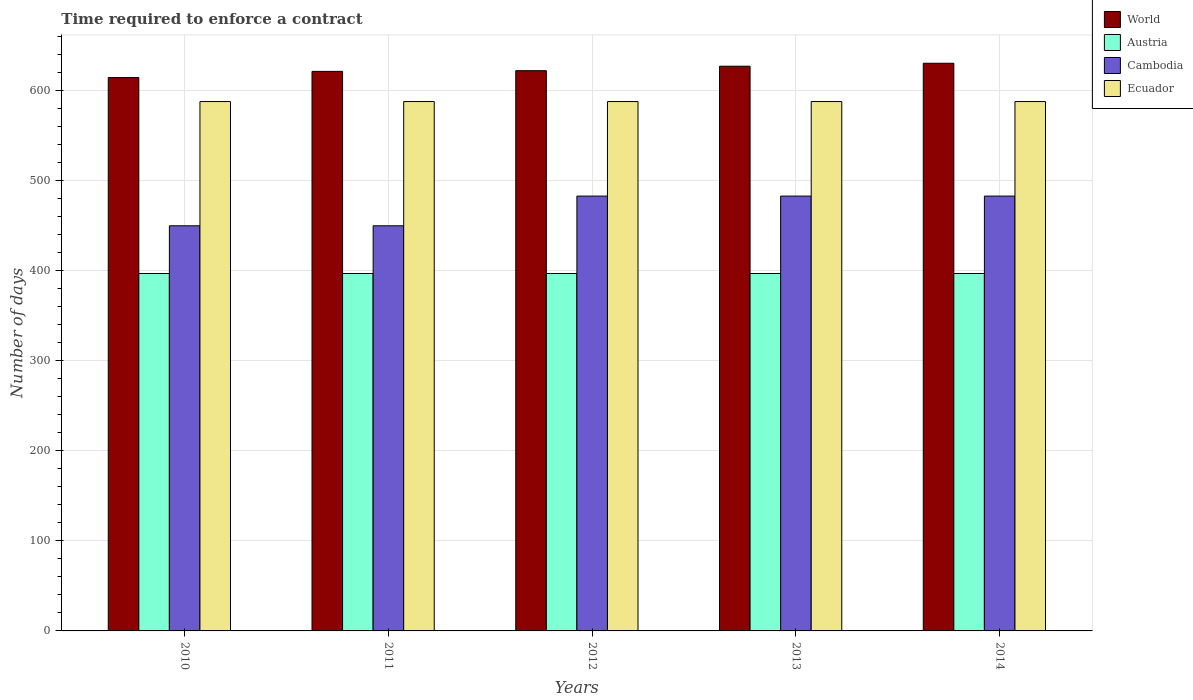What is the label of the 4th group of bars from the left?
Give a very brief answer. 2013. What is the number of days required to enforce a contract in Cambodia in 2014?
Your answer should be very brief. 483. Across all years, what is the maximum number of days required to enforce a contract in Cambodia?
Make the answer very short. 483. Across all years, what is the minimum number of days required to enforce a contract in World?
Your response must be concise. 614.64. In which year was the number of days required to enforce a contract in World maximum?
Keep it short and to the point. 2014. In which year was the number of days required to enforce a contract in World minimum?
Ensure brevity in your answer.  2010. What is the total number of days required to enforce a contract in Ecuador in the graph?
Keep it short and to the point. 2940. What is the difference between the number of days required to enforce a contract in Austria in 2010 and that in 2014?
Offer a very short reply. 0. What is the difference between the number of days required to enforce a contract in Cambodia in 2011 and the number of days required to enforce a contract in Ecuador in 2013?
Your answer should be very brief. -138. What is the average number of days required to enforce a contract in Austria per year?
Your response must be concise. 397. In the year 2012, what is the difference between the number of days required to enforce a contract in Ecuador and number of days required to enforce a contract in Cambodia?
Your response must be concise. 105. What is the ratio of the number of days required to enforce a contract in Cambodia in 2010 to that in 2012?
Your answer should be very brief. 0.93. What is the difference between the highest and the second highest number of days required to enforce a contract in Ecuador?
Offer a terse response. 0. Is the sum of the number of days required to enforce a contract in Cambodia in 2011 and 2012 greater than the maximum number of days required to enforce a contract in World across all years?
Make the answer very short. Yes. Is it the case that in every year, the sum of the number of days required to enforce a contract in Cambodia and number of days required to enforce a contract in World is greater than the number of days required to enforce a contract in Austria?
Give a very brief answer. Yes. How many bars are there?
Provide a short and direct response. 20. Are all the bars in the graph horizontal?
Your response must be concise. No. Are the values on the major ticks of Y-axis written in scientific E-notation?
Keep it short and to the point. No. Does the graph contain grids?
Your response must be concise. Yes. What is the title of the graph?
Your answer should be very brief. Time required to enforce a contract. Does "Cambodia" appear as one of the legend labels in the graph?
Your answer should be very brief. Yes. What is the label or title of the X-axis?
Give a very brief answer. Years. What is the label or title of the Y-axis?
Keep it short and to the point. Number of days. What is the Number of days of World in 2010?
Offer a terse response. 614.64. What is the Number of days of Austria in 2010?
Your answer should be compact. 397. What is the Number of days in Cambodia in 2010?
Your response must be concise. 450. What is the Number of days of Ecuador in 2010?
Offer a very short reply. 588. What is the Number of days of World in 2011?
Your response must be concise. 621.51. What is the Number of days in Austria in 2011?
Make the answer very short. 397. What is the Number of days in Cambodia in 2011?
Make the answer very short. 450. What is the Number of days in Ecuador in 2011?
Keep it short and to the point. 588. What is the Number of days in World in 2012?
Ensure brevity in your answer.  622.29. What is the Number of days of Austria in 2012?
Keep it short and to the point. 397. What is the Number of days in Cambodia in 2012?
Make the answer very short. 483. What is the Number of days of Ecuador in 2012?
Your response must be concise. 588. What is the Number of days in World in 2013?
Offer a very short reply. 627.26. What is the Number of days in Austria in 2013?
Offer a terse response. 397. What is the Number of days of Cambodia in 2013?
Keep it short and to the point. 483. What is the Number of days in Ecuador in 2013?
Provide a succinct answer. 588. What is the Number of days in World in 2014?
Your response must be concise. 630.54. What is the Number of days in Austria in 2014?
Give a very brief answer. 397. What is the Number of days in Cambodia in 2014?
Your response must be concise. 483. What is the Number of days in Ecuador in 2014?
Provide a succinct answer. 588. Across all years, what is the maximum Number of days of World?
Offer a very short reply. 630.54. Across all years, what is the maximum Number of days of Austria?
Your answer should be compact. 397. Across all years, what is the maximum Number of days of Cambodia?
Your answer should be compact. 483. Across all years, what is the maximum Number of days in Ecuador?
Your response must be concise. 588. Across all years, what is the minimum Number of days in World?
Your answer should be very brief. 614.64. Across all years, what is the minimum Number of days of Austria?
Provide a short and direct response. 397. Across all years, what is the minimum Number of days in Cambodia?
Ensure brevity in your answer.  450. Across all years, what is the minimum Number of days of Ecuador?
Provide a short and direct response. 588. What is the total Number of days of World in the graph?
Keep it short and to the point. 3116.23. What is the total Number of days of Austria in the graph?
Offer a very short reply. 1985. What is the total Number of days in Cambodia in the graph?
Your answer should be very brief. 2349. What is the total Number of days in Ecuador in the graph?
Your answer should be very brief. 2940. What is the difference between the Number of days in World in 2010 and that in 2011?
Offer a very short reply. -6.87. What is the difference between the Number of days in Austria in 2010 and that in 2011?
Offer a terse response. 0. What is the difference between the Number of days in Cambodia in 2010 and that in 2011?
Your response must be concise. 0. What is the difference between the Number of days in World in 2010 and that in 2012?
Give a very brief answer. -7.65. What is the difference between the Number of days of Austria in 2010 and that in 2012?
Your answer should be compact. 0. What is the difference between the Number of days of Cambodia in 2010 and that in 2012?
Give a very brief answer. -33. What is the difference between the Number of days of World in 2010 and that in 2013?
Ensure brevity in your answer.  -12.62. What is the difference between the Number of days in Austria in 2010 and that in 2013?
Provide a succinct answer. 0. What is the difference between the Number of days of Cambodia in 2010 and that in 2013?
Your answer should be very brief. -33. What is the difference between the Number of days of Ecuador in 2010 and that in 2013?
Offer a very short reply. 0. What is the difference between the Number of days of World in 2010 and that in 2014?
Offer a very short reply. -15.9. What is the difference between the Number of days of Austria in 2010 and that in 2014?
Your response must be concise. 0. What is the difference between the Number of days of Cambodia in 2010 and that in 2014?
Provide a short and direct response. -33. What is the difference between the Number of days in Ecuador in 2010 and that in 2014?
Give a very brief answer. 0. What is the difference between the Number of days of World in 2011 and that in 2012?
Your response must be concise. -0.78. What is the difference between the Number of days in Cambodia in 2011 and that in 2012?
Your answer should be very brief. -33. What is the difference between the Number of days of World in 2011 and that in 2013?
Ensure brevity in your answer.  -5.75. What is the difference between the Number of days of Cambodia in 2011 and that in 2013?
Offer a terse response. -33. What is the difference between the Number of days of World in 2011 and that in 2014?
Offer a terse response. -9.03. What is the difference between the Number of days in Cambodia in 2011 and that in 2014?
Give a very brief answer. -33. What is the difference between the Number of days in World in 2012 and that in 2013?
Offer a terse response. -4.97. What is the difference between the Number of days in Cambodia in 2012 and that in 2013?
Your response must be concise. 0. What is the difference between the Number of days in Ecuador in 2012 and that in 2013?
Make the answer very short. 0. What is the difference between the Number of days of World in 2012 and that in 2014?
Offer a terse response. -8.25. What is the difference between the Number of days of Austria in 2012 and that in 2014?
Offer a terse response. 0. What is the difference between the Number of days of World in 2013 and that in 2014?
Your answer should be very brief. -3.28. What is the difference between the Number of days in World in 2010 and the Number of days in Austria in 2011?
Your answer should be very brief. 217.64. What is the difference between the Number of days in World in 2010 and the Number of days in Cambodia in 2011?
Offer a very short reply. 164.64. What is the difference between the Number of days of World in 2010 and the Number of days of Ecuador in 2011?
Your response must be concise. 26.64. What is the difference between the Number of days of Austria in 2010 and the Number of days of Cambodia in 2011?
Your response must be concise. -53. What is the difference between the Number of days in Austria in 2010 and the Number of days in Ecuador in 2011?
Make the answer very short. -191. What is the difference between the Number of days in Cambodia in 2010 and the Number of days in Ecuador in 2011?
Your answer should be very brief. -138. What is the difference between the Number of days in World in 2010 and the Number of days in Austria in 2012?
Your answer should be very brief. 217.64. What is the difference between the Number of days of World in 2010 and the Number of days of Cambodia in 2012?
Offer a very short reply. 131.64. What is the difference between the Number of days of World in 2010 and the Number of days of Ecuador in 2012?
Offer a terse response. 26.64. What is the difference between the Number of days in Austria in 2010 and the Number of days in Cambodia in 2012?
Give a very brief answer. -86. What is the difference between the Number of days in Austria in 2010 and the Number of days in Ecuador in 2012?
Your answer should be very brief. -191. What is the difference between the Number of days in Cambodia in 2010 and the Number of days in Ecuador in 2012?
Offer a very short reply. -138. What is the difference between the Number of days of World in 2010 and the Number of days of Austria in 2013?
Ensure brevity in your answer.  217.64. What is the difference between the Number of days in World in 2010 and the Number of days in Cambodia in 2013?
Give a very brief answer. 131.64. What is the difference between the Number of days in World in 2010 and the Number of days in Ecuador in 2013?
Provide a succinct answer. 26.64. What is the difference between the Number of days of Austria in 2010 and the Number of days of Cambodia in 2013?
Provide a short and direct response. -86. What is the difference between the Number of days of Austria in 2010 and the Number of days of Ecuador in 2013?
Provide a short and direct response. -191. What is the difference between the Number of days of Cambodia in 2010 and the Number of days of Ecuador in 2013?
Offer a very short reply. -138. What is the difference between the Number of days in World in 2010 and the Number of days in Austria in 2014?
Your response must be concise. 217.64. What is the difference between the Number of days in World in 2010 and the Number of days in Cambodia in 2014?
Your answer should be very brief. 131.64. What is the difference between the Number of days in World in 2010 and the Number of days in Ecuador in 2014?
Your answer should be compact. 26.64. What is the difference between the Number of days of Austria in 2010 and the Number of days of Cambodia in 2014?
Your answer should be very brief. -86. What is the difference between the Number of days in Austria in 2010 and the Number of days in Ecuador in 2014?
Offer a very short reply. -191. What is the difference between the Number of days in Cambodia in 2010 and the Number of days in Ecuador in 2014?
Keep it short and to the point. -138. What is the difference between the Number of days of World in 2011 and the Number of days of Austria in 2012?
Provide a succinct answer. 224.51. What is the difference between the Number of days in World in 2011 and the Number of days in Cambodia in 2012?
Your answer should be compact. 138.51. What is the difference between the Number of days in World in 2011 and the Number of days in Ecuador in 2012?
Offer a very short reply. 33.51. What is the difference between the Number of days in Austria in 2011 and the Number of days in Cambodia in 2012?
Ensure brevity in your answer.  -86. What is the difference between the Number of days in Austria in 2011 and the Number of days in Ecuador in 2012?
Your response must be concise. -191. What is the difference between the Number of days of Cambodia in 2011 and the Number of days of Ecuador in 2012?
Keep it short and to the point. -138. What is the difference between the Number of days in World in 2011 and the Number of days in Austria in 2013?
Keep it short and to the point. 224.51. What is the difference between the Number of days of World in 2011 and the Number of days of Cambodia in 2013?
Make the answer very short. 138.51. What is the difference between the Number of days of World in 2011 and the Number of days of Ecuador in 2013?
Make the answer very short. 33.51. What is the difference between the Number of days of Austria in 2011 and the Number of days of Cambodia in 2013?
Offer a very short reply. -86. What is the difference between the Number of days of Austria in 2011 and the Number of days of Ecuador in 2013?
Ensure brevity in your answer.  -191. What is the difference between the Number of days of Cambodia in 2011 and the Number of days of Ecuador in 2013?
Your response must be concise. -138. What is the difference between the Number of days of World in 2011 and the Number of days of Austria in 2014?
Your answer should be compact. 224.51. What is the difference between the Number of days in World in 2011 and the Number of days in Cambodia in 2014?
Offer a very short reply. 138.51. What is the difference between the Number of days of World in 2011 and the Number of days of Ecuador in 2014?
Provide a short and direct response. 33.51. What is the difference between the Number of days of Austria in 2011 and the Number of days of Cambodia in 2014?
Your response must be concise. -86. What is the difference between the Number of days in Austria in 2011 and the Number of days in Ecuador in 2014?
Give a very brief answer. -191. What is the difference between the Number of days in Cambodia in 2011 and the Number of days in Ecuador in 2014?
Keep it short and to the point. -138. What is the difference between the Number of days in World in 2012 and the Number of days in Austria in 2013?
Offer a very short reply. 225.29. What is the difference between the Number of days in World in 2012 and the Number of days in Cambodia in 2013?
Give a very brief answer. 139.29. What is the difference between the Number of days of World in 2012 and the Number of days of Ecuador in 2013?
Offer a terse response. 34.29. What is the difference between the Number of days of Austria in 2012 and the Number of days of Cambodia in 2013?
Provide a short and direct response. -86. What is the difference between the Number of days in Austria in 2012 and the Number of days in Ecuador in 2013?
Provide a succinct answer. -191. What is the difference between the Number of days of Cambodia in 2012 and the Number of days of Ecuador in 2013?
Provide a short and direct response. -105. What is the difference between the Number of days in World in 2012 and the Number of days in Austria in 2014?
Make the answer very short. 225.29. What is the difference between the Number of days of World in 2012 and the Number of days of Cambodia in 2014?
Give a very brief answer. 139.29. What is the difference between the Number of days in World in 2012 and the Number of days in Ecuador in 2014?
Your response must be concise. 34.29. What is the difference between the Number of days of Austria in 2012 and the Number of days of Cambodia in 2014?
Offer a terse response. -86. What is the difference between the Number of days in Austria in 2012 and the Number of days in Ecuador in 2014?
Make the answer very short. -191. What is the difference between the Number of days in Cambodia in 2012 and the Number of days in Ecuador in 2014?
Provide a short and direct response. -105. What is the difference between the Number of days of World in 2013 and the Number of days of Austria in 2014?
Your answer should be compact. 230.26. What is the difference between the Number of days in World in 2013 and the Number of days in Cambodia in 2014?
Your answer should be compact. 144.26. What is the difference between the Number of days of World in 2013 and the Number of days of Ecuador in 2014?
Ensure brevity in your answer.  39.26. What is the difference between the Number of days of Austria in 2013 and the Number of days of Cambodia in 2014?
Keep it short and to the point. -86. What is the difference between the Number of days of Austria in 2013 and the Number of days of Ecuador in 2014?
Your answer should be compact. -191. What is the difference between the Number of days in Cambodia in 2013 and the Number of days in Ecuador in 2014?
Give a very brief answer. -105. What is the average Number of days in World per year?
Provide a short and direct response. 623.25. What is the average Number of days of Austria per year?
Your response must be concise. 397. What is the average Number of days of Cambodia per year?
Give a very brief answer. 469.8. What is the average Number of days of Ecuador per year?
Make the answer very short. 588. In the year 2010, what is the difference between the Number of days in World and Number of days in Austria?
Provide a succinct answer. 217.64. In the year 2010, what is the difference between the Number of days of World and Number of days of Cambodia?
Provide a short and direct response. 164.64. In the year 2010, what is the difference between the Number of days of World and Number of days of Ecuador?
Ensure brevity in your answer.  26.64. In the year 2010, what is the difference between the Number of days of Austria and Number of days of Cambodia?
Ensure brevity in your answer.  -53. In the year 2010, what is the difference between the Number of days in Austria and Number of days in Ecuador?
Offer a very short reply. -191. In the year 2010, what is the difference between the Number of days in Cambodia and Number of days in Ecuador?
Ensure brevity in your answer.  -138. In the year 2011, what is the difference between the Number of days of World and Number of days of Austria?
Ensure brevity in your answer.  224.51. In the year 2011, what is the difference between the Number of days of World and Number of days of Cambodia?
Keep it short and to the point. 171.51. In the year 2011, what is the difference between the Number of days of World and Number of days of Ecuador?
Provide a succinct answer. 33.51. In the year 2011, what is the difference between the Number of days in Austria and Number of days in Cambodia?
Provide a succinct answer. -53. In the year 2011, what is the difference between the Number of days in Austria and Number of days in Ecuador?
Provide a succinct answer. -191. In the year 2011, what is the difference between the Number of days of Cambodia and Number of days of Ecuador?
Offer a terse response. -138. In the year 2012, what is the difference between the Number of days in World and Number of days in Austria?
Make the answer very short. 225.29. In the year 2012, what is the difference between the Number of days in World and Number of days in Cambodia?
Give a very brief answer. 139.29. In the year 2012, what is the difference between the Number of days in World and Number of days in Ecuador?
Your answer should be very brief. 34.29. In the year 2012, what is the difference between the Number of days of Austria and Number of days of Cambodia?
Provide a short and direct response. -86. In the year 2012, what is the difference between the Number of days in Austria and Number of days in Ecuador?
Your answer should be compact. -191. In the year 2012, what is the difference between the Number of days of Cambodia and Number of days of Ecuador?
Offer a terse response. -105. In the year 2013, what is the difference between the Number of days in World and Number of days in Austria?
Your answer should be very brief. 230.26. In the year 2013, what is the difference between the Number of days of World and Number of days of Cambodia?
Provide a succinct answer. 144.26. In the year 2013, what is the difference between the Number of days of World and Number of days of Ecuador?
Offer a terse response. 39.26. In the year 2013, what is the difference between the Number of days of Austria and Number of days of Cambodia?
Your answer should be very brief. -86. In the year 2013, what is the difference between the Number of days of Austria and Number of days of Ecuador?
Keep it short and to the point. -191. In the year 2013, what is the difference between the Number of days of Cambodia and Number of days of Ecuador?
Provide a succinct answer. -105. In the year 2014, what is the difference between the Number of days in World and Number of days in Austria?
Give a very brief answer. 233.54. In the year 2014, what is the difference between the Number of days in World and Number of days in Cambodia?
Keep it short and to the point. 147.54. In the year 2014, what is the difference between the Number of days of World and Number of days of Ecuador?
Offer a very short reply. 42.54. In the year 2014, what is the difference between the Number of days of Austria and Number of days of Cambodia?
Provide a short and direct response. -86. In the year 2014, what is the difference between the Number of days of Austria and Number of days of Ecuador?
Your answer should be very brief. -191. In the year 2014, what is the difference between the Number of days of Cambodia and Number of days of Ecuador?
Provide a short and direct response. -105. What is the ratio of the Number of days in World in 2010 to that in 2011?
Ensure brevity in your answer.  0.99. What is the ratio of the Number of days in Austria in 2010 to that in 2011?
Ensure brevity in your answer.  1. What is the ratio of the Number of days of Cambodia in 2010 to that in 2011?
Keep it short and to the point. 1. What is the ratio of the Number of days in Ecuador in 2010 to that in 2011?
Your answer should be compact. 1. What is the ratio of the Number of days of World in 2010 to that in 2012?
Your answer should be compact. 0.99. What is the ratio of the Number of days in Austria in 2010 to that in 2012?
Ensure brevity in your answer.  1. What is the ratio of the Number of days of Cambodia in 2010 to that in 2012?
Give a very brief answer. 0.93. What is the ratio of the Number of days of World in 2010 to that in 2013?
Your answer should be compact. 0.98. What is the ratio of the Number of days in Cambodia in 2010 to that in 2013?
Ensure brevity in your answer.  0.93. What is the ratio of the Number of days of World in 2010 to that in 2014?
Your response must be concise. 0.97. What is the ratio of the Number of days of Austria in 2010 to that in 2014?
Ensure brevity in your answer.  1. What is the ratio of the Number of days of Cambodia in 2010 to that in 2014?
Provide a succinct answer. 0.93. What is the ratio of the Number of days of Austria in 2011 to that in 2012?
Offer a very short reply. 1. What is the ratio of the Number of days in Cambodia in 2011 to that in 2012?
Ensure brevity in your answer.  0.93. What is the ratio of the Number of days of Ecuador in 2011 to that in 2012?
Your answer should be compact. 1. What is the ratio of the Number of days of Austria in 2011 to that in 2013?
Offer a terse response. 1. What is the ratio of the Number of days in Cambodia in 2011 to that in 2013?
Offer a very short reply. 0.93. What is the ratio of the Number of days of World in 2011 to that in 2014?
Make the answer very short. 0.99. What is the ratio of the Number of days in Cambodia in 2011 to that in 2014?
Offer a terse response. 0.93. What is the ratio of the Number of days of Ecuador in 2012 to that in 2013?
Provide a short and direct response. 1. What is the ratio of the Number of days of World in 2012 to that in 2014?
Offer a terse response. 0.99. What is the ratio of the Number of days in Cambodia in 2012 to that in 2014?
Give a very brief answer. 1. What is the ratio of the Number of days of Ecuador in 2012 to that in 2014?
Give a very brief answer. 1. What is the ratio of the Number of days in Austria in 2013 to that in 2014?
Make the answer very short. 1. What is the ratio of the Number of days in Cambodia in 2013 to that in 2014?
Keep it short and to the point. 1. What is the ratio of the Number of days of Ecuador in 2013 to that in 2014?
Give a very brief answer. 1. What is the difference between the highest and the second highest Number of days of World?
Offer a terse response. 3.28. What is the difference between the highest and the second highest Number of days in Austria?
Ensure brevity in your answer.  0. What is the difference between the highest and the second highest Number of days of Cambodia?
Keep it short and to the point. 0. What is the difference between the highest and the lowest Number of days in World?
Your response must be concise. 15.9. What is the difference between the highest and the lowest Number of days in Cambodia?
Give a very brief answer. 33. 